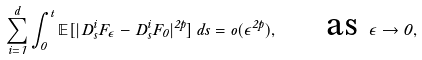Convert formula to latex. <formula><loc_0><loc_0><loc_500><loc_500>\sum _ { i = 1 } ^ { d } \int _ { 0 } ^ { t } \mathbb { E } [ | D _ { s } ^ { i } F _ { \epsilon } - D _ { s } ^ { i } F _ { 0 } | ^ { 2 p } ] \, d s = o ( \epsilon ^ { 2 p } ) , \quad \text { as } \epsilon \rightarrow 0 ,</formula> 